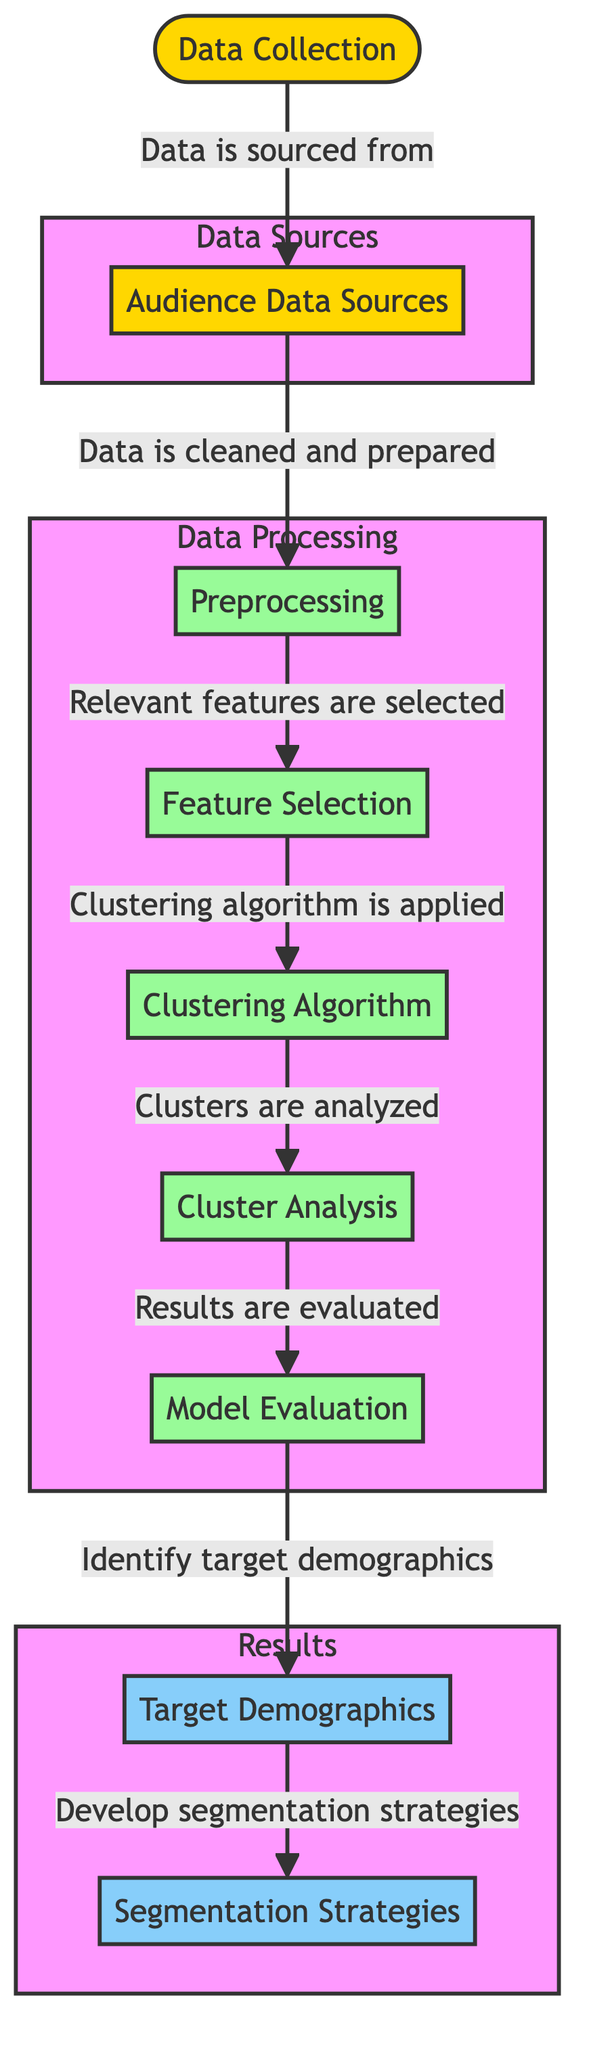What is the first step in the diagram? The diagram begins with "Data Collection," as it is the initial node that indicates the starting point of the process.
Answer: Data Collection How many main processes are depicted in the diagram? By counting the nodes labeled as processes, there are five main processes: Preprocessing, Feature Selection, Clustering Algorithm, Cluster Analysis, and Model Evaluation.
Answer: Five What connects Data Collection to Audience Data Sources? The arrow labeled "Data is sourced from" connects the node "Data Collection" to "Audience Data Sources," indicating the flow of data into the next step.
Answer: Data is sourced from Which node follows the Feature Selection node? The node that follows "Feature Selection" is "Clustering Algorithm," as indicated by the arrow showing the direction of the workflow.
Answer: Clustering Algorithm What are the two results obtained after the Model Evaluation step? The two results obtained are "Target Demographics" and "Segmentation Strategies," which are the output from the final process in the diagram.
Answer: Target Demographics and Segmentation Strategies Explain the relationship between Cluster Analysis and Model Evaluation. The "Cluster Analysis" node leads to "Model Evaluation" as indicated by the connecting arrow, which shows that the analysis of clusters is essential before evaluating the model.
Answer: Cluster Analysis leads to Model Evaluation Which process is responsible for cleaning and preparing the data? The process responsible for cleaning and preparing the data is "Preprocessing," as it is explicitly mentioned after Data Sources within the Data Processing subgraph.
Answer: Preprocessing How do you identify the target demographics according to the diagram? To identify the target demographics, the final step "Identify target demographics" follows the "Model Evaluation," showing that the evaluation step is crucial for this identification.
Answer: Identify target demographics What is the last step illustrated in the flowchart? The last step illustrated in the flowchart is "Segmentation Strategies," which is the terminal node in the Results subgraph that follows the identification of target demographics.
Answer: Segmentation Strategies 